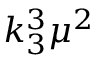Convert formula to latex. <formula><loc_0><loc_0><loc_500><loc_500>k _ { 3 } ^ { 3 } \mu ^ { 2 }</formula> 